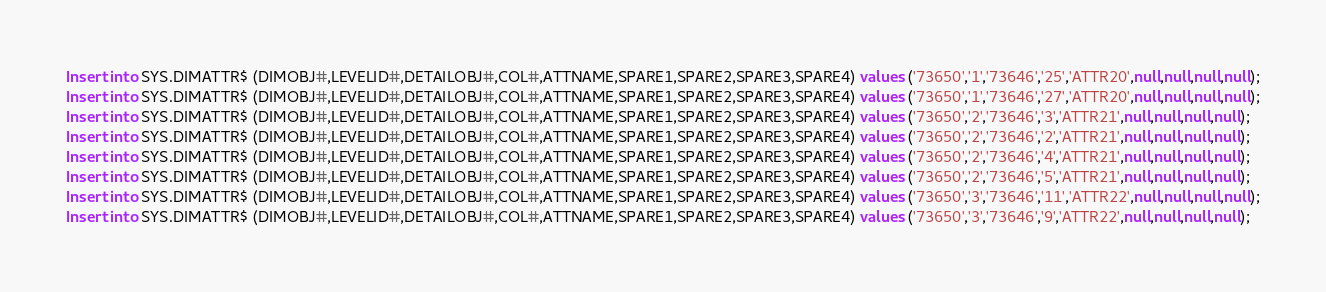<code> <loc_0><loc_0><loc_500><loc_500><_SQL_>Insert into SYS.DIMATTR$ (DIMOBJ#,LEVELID#,DETAILOBJ#,COL#,ATTNAME,SPARE1,SPARE2,SPARE3,SPARE4) values ('73650','1','73646','25','ATTR20',null,null,null,null);
Insert into SYS.DIMATTR$ (DIMOBJ#,LEVELID#,DETAILOBJ#,COL#,ATTNAME,SPARE1,SPARE2,SPARE3,SPARE4) values ('73650','1','73646','27','ATTR20',null,null,null,null);
Insert into SYS.DIMATTR$ (DIMOBJ#,LEVELID#,DETAILOBJ#,COL#,ATTNAME,SPARE1,SPARE2,SPARE3,SPARE4) values ('73650','2','73646','3','ATTR21',null,null,null,null);
Insert into SYS.DIMATTR$ (DIMOBJ#,LEVELID#,DETAILOBJ#,COL#,ATTNAME,SPARE1,SPARE2,SPARE3,SPARE4) values ('73650','2','73646','2','ATTR21',null,null,null,null);
Insert into SYS.DIMATTR$ (DIMOBJ#,LEVELID#,DETAILOBJ#,COL#,ATTNAME,SPARE1,SPARE2,SPARE3,SPARE4) values ('73650','2','73646','4','ATTR21',null,null,null,null);
Insert into SYS.DIMATTR$ (DIMOBJ#,LEVELID#,DETAILOBJ#,COL#,ATTNAME,SPARE1,SPARE2,SPARE3,SPARE4) values ('73650','2','73646','5','ATTR21',null,null,null,null);
Insert into SYS.DIMATTR$ (DIMOBJ#,LEVELID#,DETAILOBJ#,COL#,ATTNAME,SPARE1,SPARE2,SPARE3,SPARE4) values ('73650','3','73646','11','ATTR22',null,null,null,null);
Insert into SYS.DIMATTR$ (DIMOBJ#,LEVELID#,DETAILOBJ#,COL#,ATTNAME,SPARE1,SPARE2,SPARE3,SPARE4) values ('73650','3','73646','9','ATTR22',null,null,null,null);</code> 